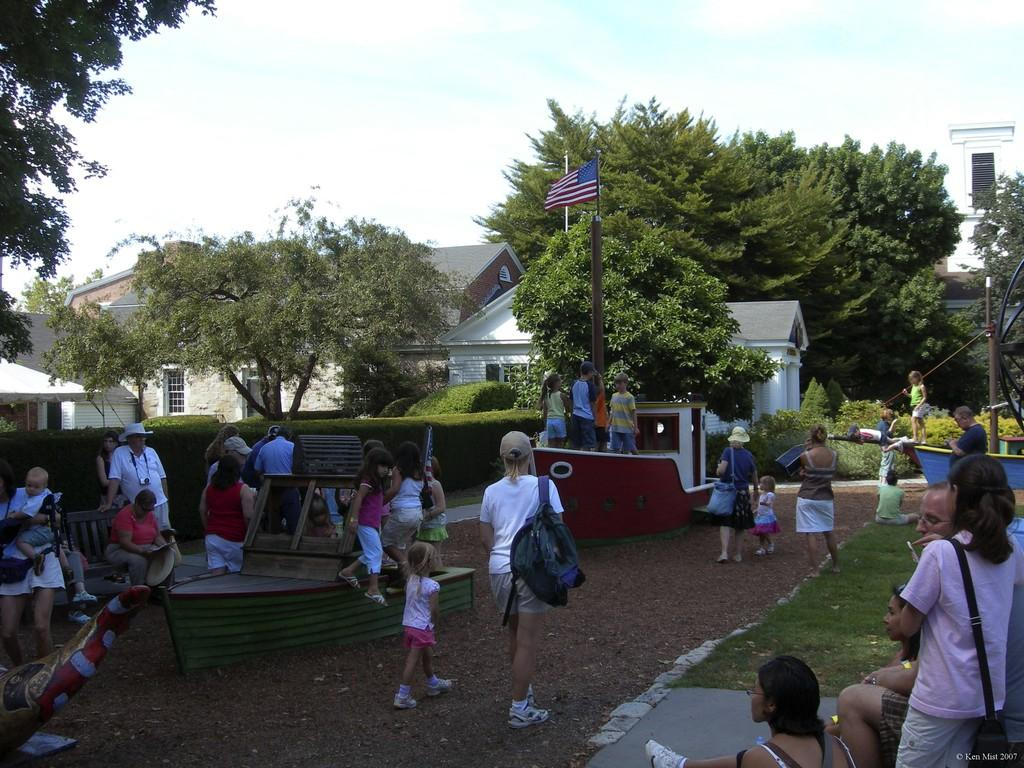What is the main subject in the center of the image? There are people in the center of the image. What can be seen in the background of the image? There are houses and trees in the background of the image. What is the additional object in the image? There is a flag in the image. What is visible at the top of the image? The sky is visible at the top of the image. What type of coach can be seen driving through the houses in the image? There is no coach present in the image; it only features people, houses, trees, a flag, and the sky. What color is the pig wearing a sweater in the image? There is no pig or sweater present in the image. 